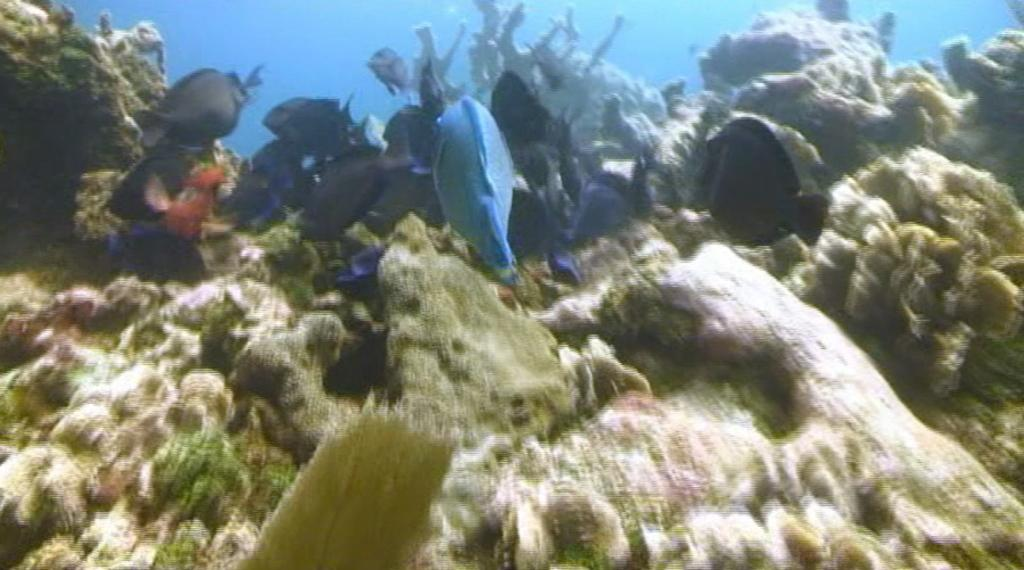What type of animals can be seen in the image? There are fish in the water. What else can be seen in the water besides the fish? There are underwater plants visible in the image. What type of spade is being used by the fish in the image? There is no spade present in the image; it features fish and underwater plants. How many birds are in the flock that is flying over the water in the image? There is no flock of birds present in the image; it only features fish and underwater plants. 